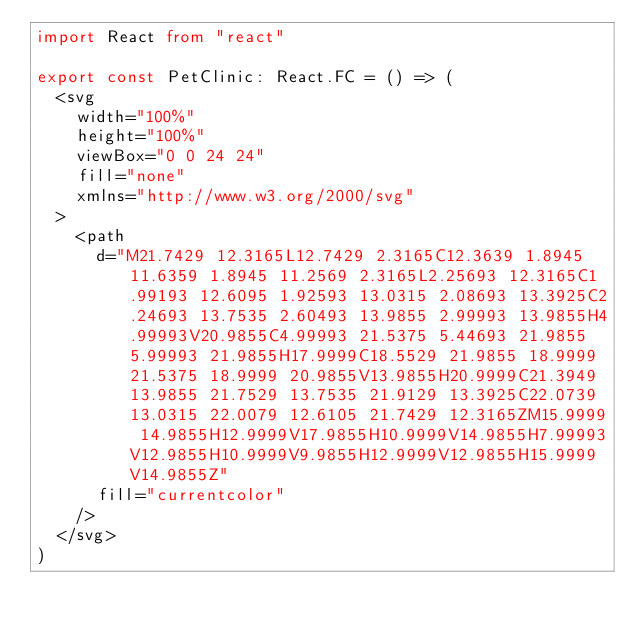Convert code to text. <code><loc_0><loc_0><loc_500><loc_500><_TypeScript_>import React from "react"

export const PetClinic: React.FC = () => (
  <svg
    width="100%"
    height="100%"
    viewBox="0 0 24 24"
    fill="none"
    xmlns="http://www.w3.org/2000/svg"
  >
    <path
      d="M21.7429 12.3165L12.7429 2.3165C12.3639 1.8945 11.6359 1.8945 11.2569 2.3165L2.25693 12.3165C1.99193 12.6095 1.92593 13.0315 2.08693 13.3925C2.24693 13.7535 2.60493 13.9855 2.99993 13.9855H4.99993V20.9855C4.99993 21.5375 5.44693 21.9855 5.99993 21.9855H17.9999C18.5529 21.9855 18.9999 21.5375 18.9999 20.9855V13.9855H20.9999C21.3949 13.9855 21.7529 13.7535 21.9129 13.3925C22.0739 13.0315 22.0079 12.6105 21.7429 12.3165ZM15.9999 14.9855H12.9999V17.9855H10.9999V14.9855H7.99993V12.9855H10.9999V9.9855H12.9999V12.9855H15.9999V14.9855Z"
      fill="currentcolor"
    />
  </svg>
)
</code> 